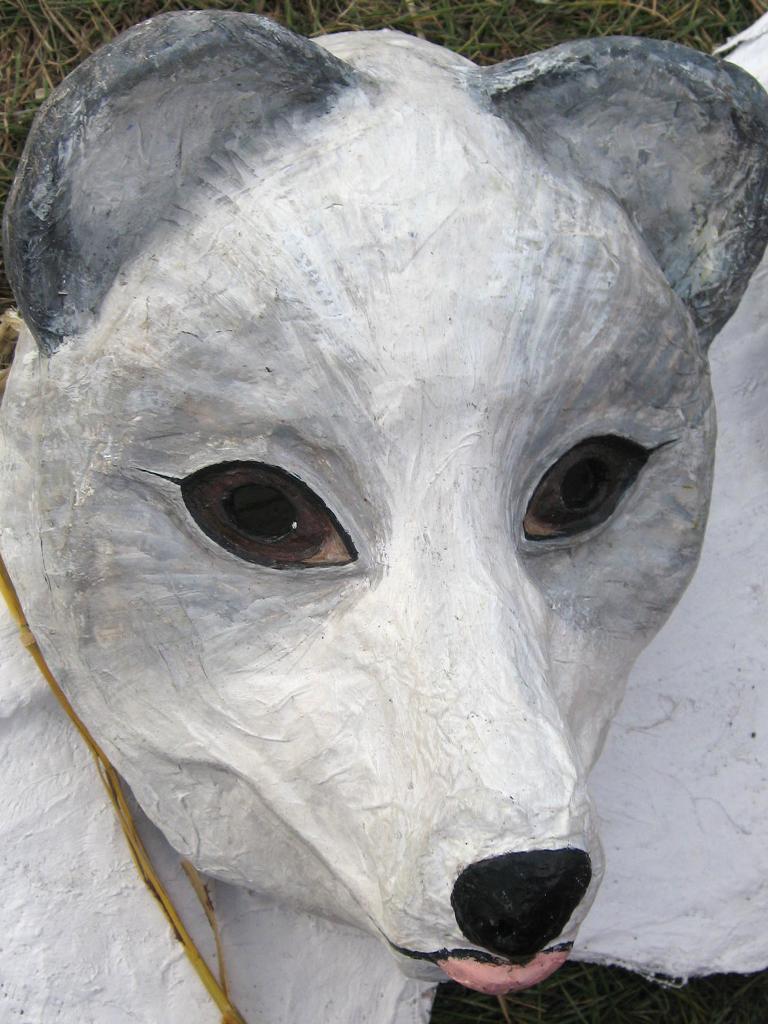Please provide a concise description of this image. This picture shows statue of a animal and we see grass. 